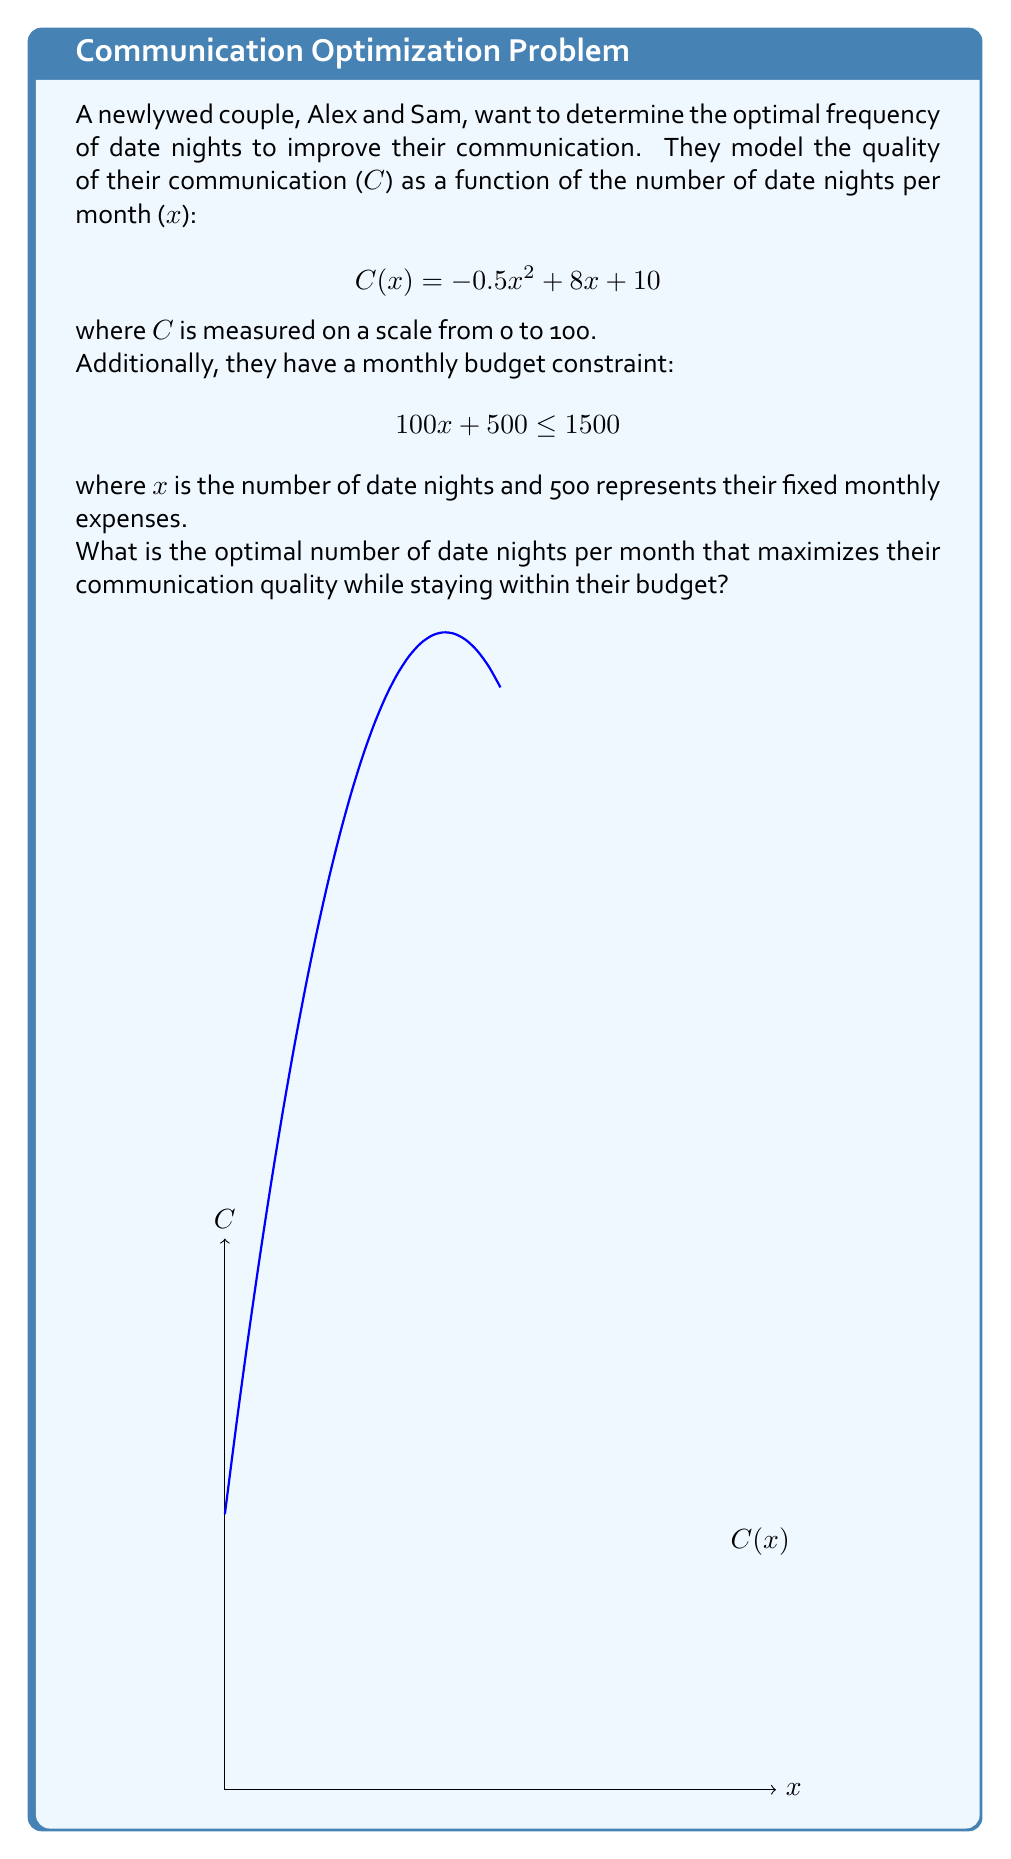Help me with this question. Let's approach this problem step by step:

1) First, we need to find the domain of x based on the budget constraint:
   $$100x + 500 \leq 1500$$
   $$100x \leq 1000$$
   $$x \leq 10$$
   
   So, x can be any number between 0 and 10.

2) Now, to find the maximum of C(x), we need to find where its derivative equals zero:
   $$C'(x) = -x + 8$$
   
   Setting this equal to zero:
   $$-x + 8 = 0$$
   $$x = 8$$

3) We need to check if x = 8 is within our domain (0 ≤ x ≤ 10). It is, so this could be our maximum.

4) To confirm it's a maximum and not a minimum, we can check the second derivative:
   $$C''(x) = -1$$
   
   Since this is negative, we confirm that x = 8 gives a maximum.

5) However, we need to check if x = 8 satisfies our budget constraint:
   $$100(8) + 500 = 1300 \leq 1500$$
   
   It does satisfy the constraint.

6) Therefore, the optimal number of date nights is 8 per month.

7) We can calculate the maximum communication quality:
   $$C(8) = -0.5(8)^2 + 8(8) + 10 = -32 + 64 + 10 = 42$$
Answer: 8 date nights per month 